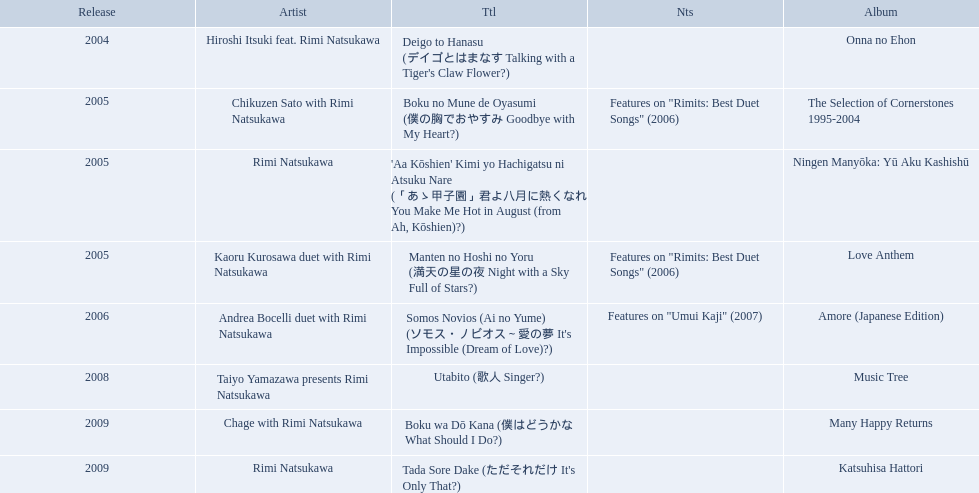What are the names of each album by rimi natsukawa? Onna no Ehon, The Selection of Cornerstones 1995-2004, Ningen Manyōka: Yū Aku Kashishū, Love Anthem, Amore (Japanese Edition), Music Tree, Many Happy Returns, Katsuhisa Hattori. And when were the albums released? 2004, 2005, 2005, 2005, 2006, 2008, 2009, 2009. Was onna no ehon or music tree released most recently? Music Tree. What year was onna no ehon released? 2004. What year was music tree released? 2008. Which of the two was not released in 2004? Music Tree. When was onna no ehon released? 2004. When was the selection of cornerstones 1995-2004 released? 2005. What was released in 2008? Music Tree. 